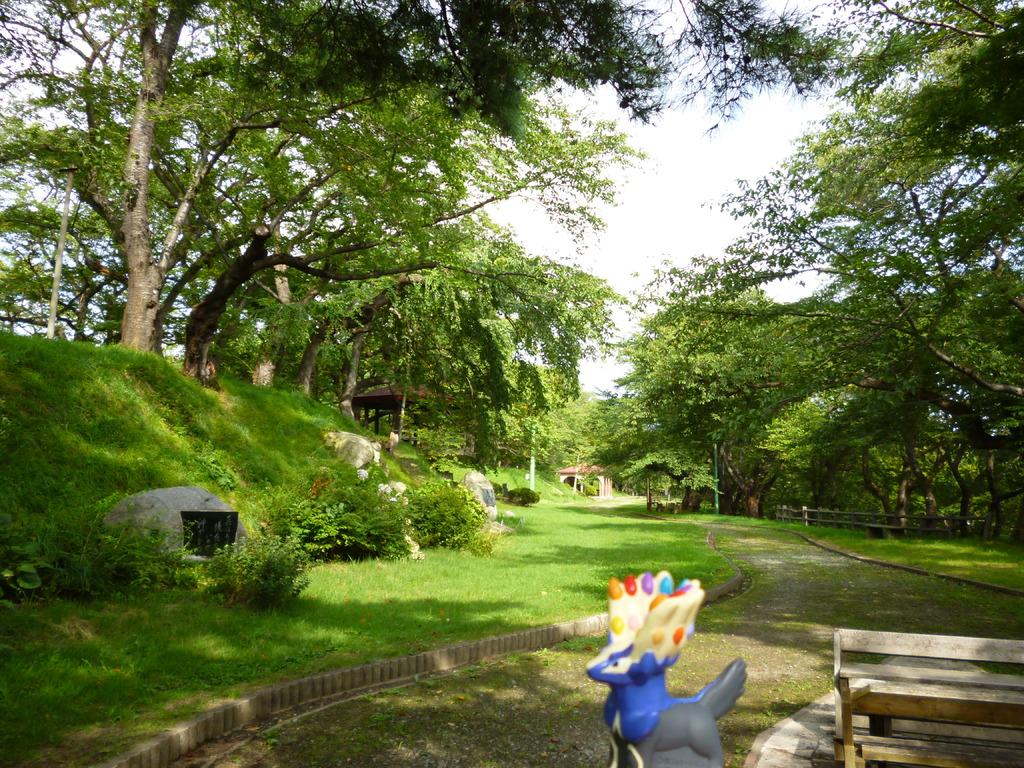What type of vegetation can be seen in the image? There are trees in the image. What is the weather like in the image? The sky is clear, indicating a sunny day. What color is the grass in the image? The grass is green. What type of seating is present in the image? There is a bench in the image. What type of object can be seen that is typically associated with playtime? There is a toy in the image. What structures can be seen in the distance? There is a tent and a fence in the distance. What type of education is being provided in the image? There is no indication of any educational activity in the image. What type of war is being depicted in the image? There is no depiction of war or any conflict in the image. What type of can is visible in the image? There is no can present in the image. 